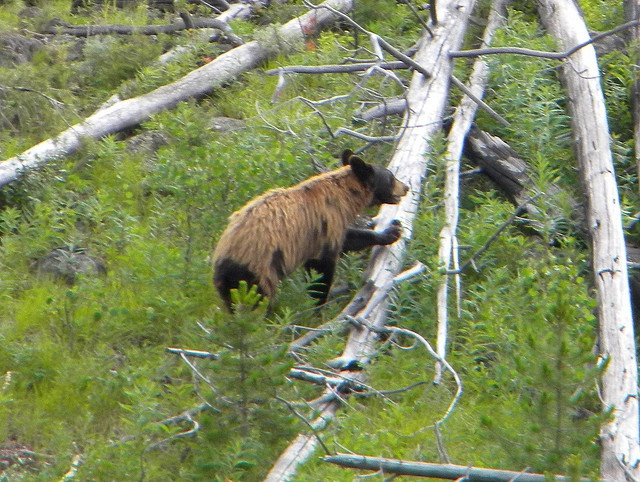Describe the objects in this image and their specific colors. I can see a bear in black, gray, and tan tones in this image. 